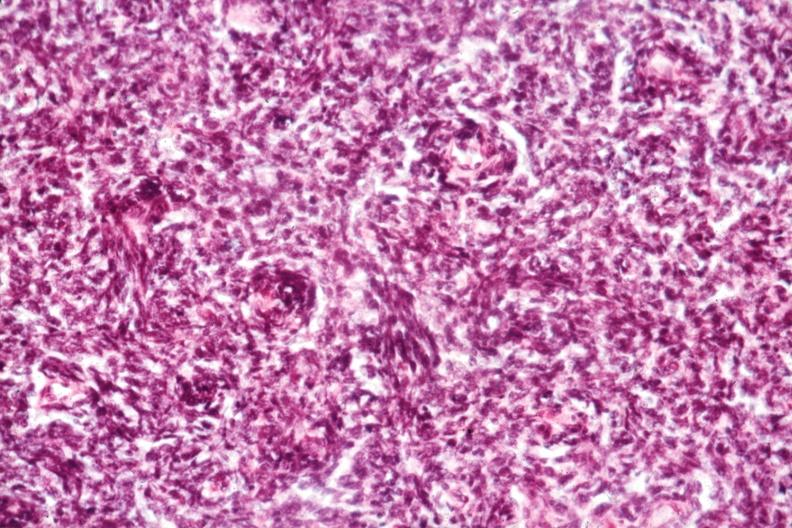s fat necrosis present?
Answer the question using a single word or phrase. No 